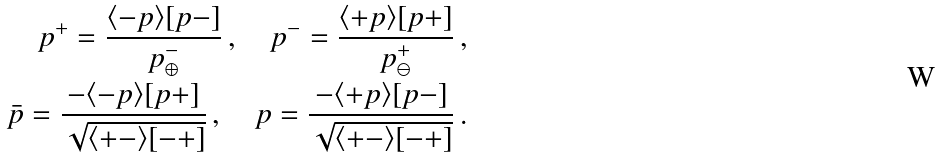<formula> <loc_0><loc_0><loc_500><loc_500>p ^ { + } = \frac { \langle - p \rangle [ p - ] } { p ^ { - } _ { \oplus } } \, , \quad p ^ { - } = \frac { \langle + p \rangle [ p + ] } { p ^ { + } _ { \ominus } } \, , \\ \bar { p } = \frac { - \langle - p \rangle [ p + ] } { \sqrt { \langle + - \rangle [ - + ] } } \, , \quad p = \frac { - \langle + p \rangle [ p - ] } { \sqrt { \langle + - \rangle [ - + ] } } \, .</formula> 